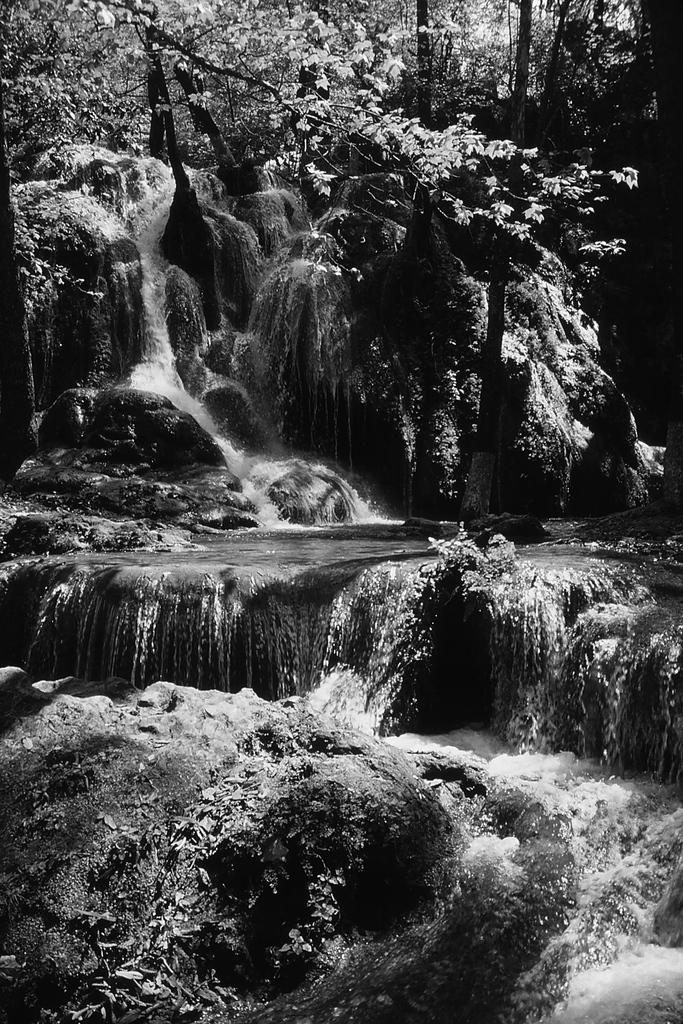What is the color scheme of the image? The image is black and white. What natural feature can be seen in the image? There is a waterfall in the image. What type of vegetation is present in the image? There are multiple trees in the image. Where are the scissors located in the image? There are no scissors present in the image. What type of creature is the scarecrow guarding in the image? There is no scarecrow present in the image. What type of boundary can be seen in the image? There is no boundary present in the image. 